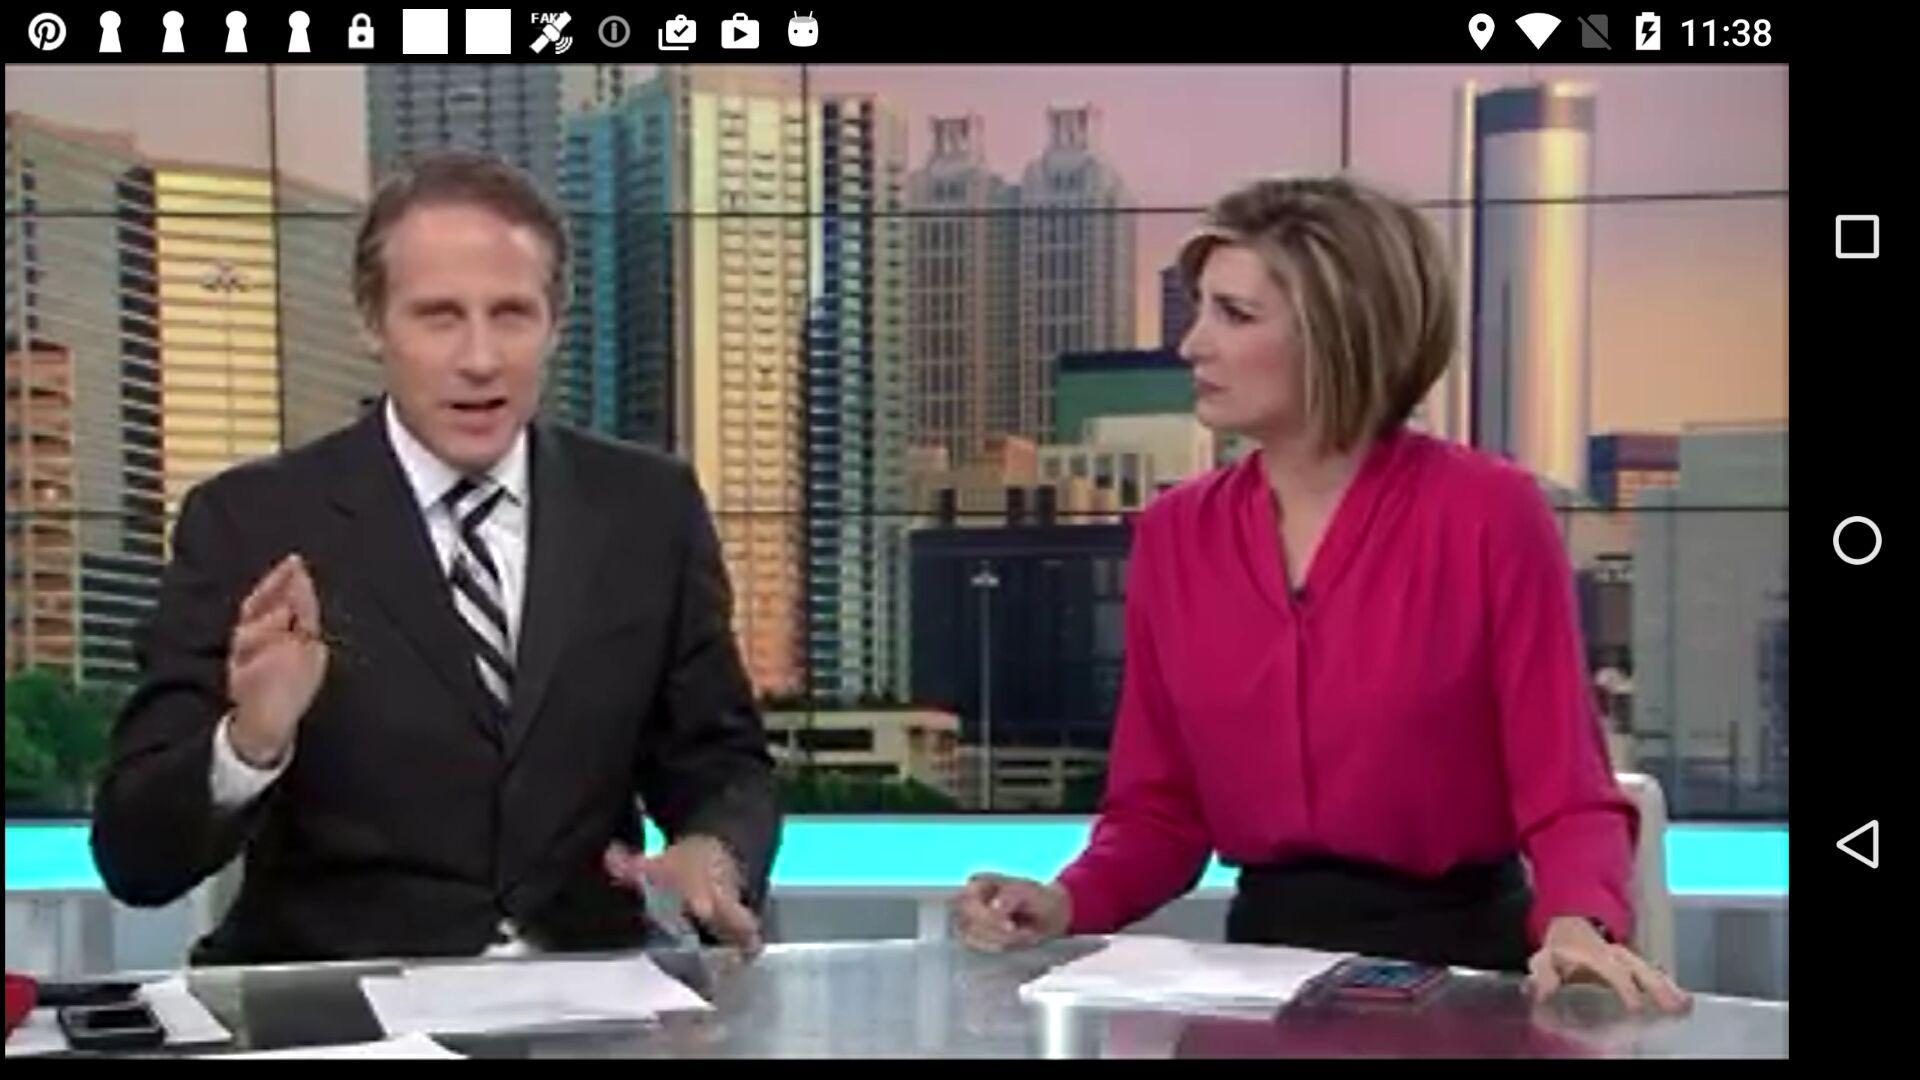What is the number of districts?
When the provided information is insufficient, respond with <no answer>. <no answer> 